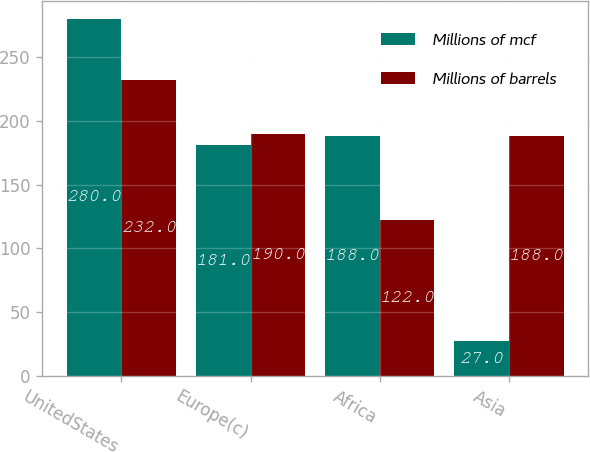<chart> <loc_0><loc_0><loc_500><loc_500><stacked_bar_chart><ecel><fcel>UnitedStates<fcel>Europe(c)<fcel>Africa<fcel>Asia<nl><fcel>Millions of mcf<fcel>280<fcel>181<fcel>188<fcel>27<nl><fcel>Millions of barrels<fcel>232<fcel>190<fcel>122<fcel>188<nl></chart> 